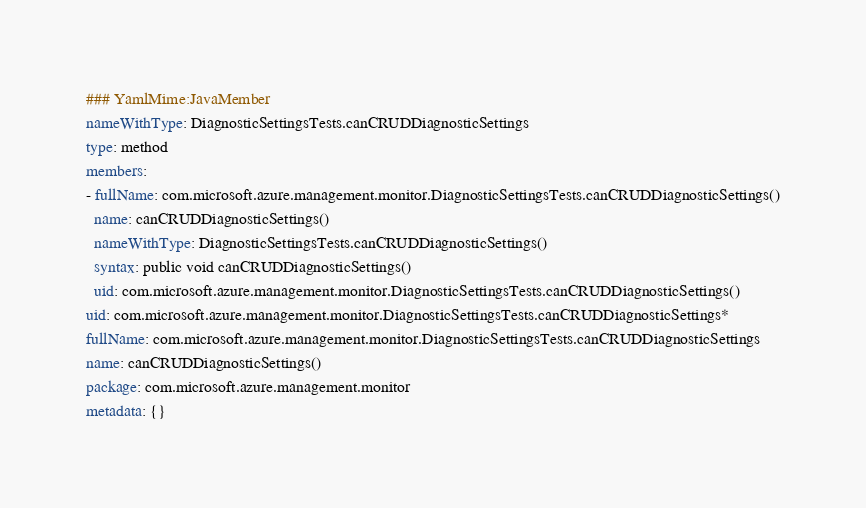<code> <loc_0><loc_0><loc_500><loc_500><_YAML_>### YamlMime:JavaMember
nameWithType: DiagnosticSettingsTests.canCRUDDiagnosticSettings
type: method
members:
- fullName: com.microsoft.azure.management.monitor.DiagnosticSettingsTests.canCRUDDiagnosticSettings()
  name: canCRUDDiagnosticSettings()
  nameWithType: DiagnosticSettingsTests.canCRUDDiagnosticSettings()
  syntax: public void canCRUDDiagnosticSettings()
  uid: com.microsoft.azure.management.monitor.DiagnosticSettingsTests.canCRUDDiagnosticSettings()
uid: com.microsoft.azure.management.monitor.DiagnosticSettingsTests.canCRUDDiagnosticSettings*
fullName: com.microsoft.azure.management.monitor.DiagnosticSettingsTests.canCRUDDiagnosticSettings
name: canCRUDDiagnosticSettings()
package: com.microsoft.azure.management.monitor
metadata: {}
</code> 